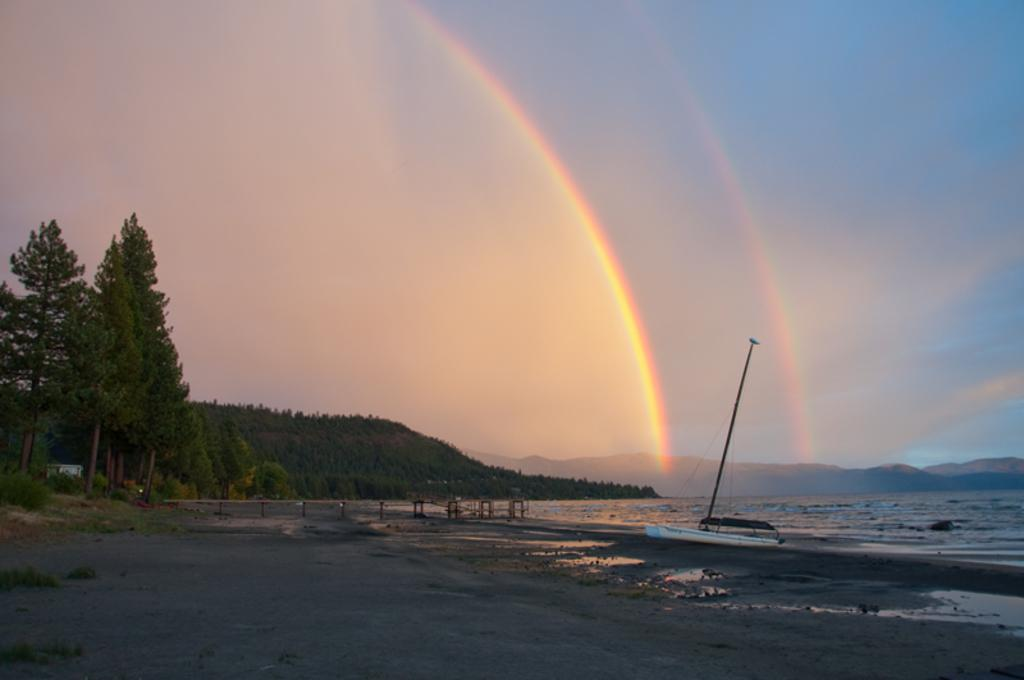What type of terrain can be seen in the image? Ground and water are visible in the image. What is located on the water in the image? There is a boat in the image. What type of vegetation is present in the image? Green trees are visible in the image. What natural phenomenon can be seen in the background of the image? There is a rainbow in the background of the image. What type of landscape is visible in the background of the image? Mountains and the sky are visible in the background of the image. What is the weight of the sweater worn by the person in the image? There is no person wearing a sweater in the image; it features a boat on water with a rainbow in the background. 